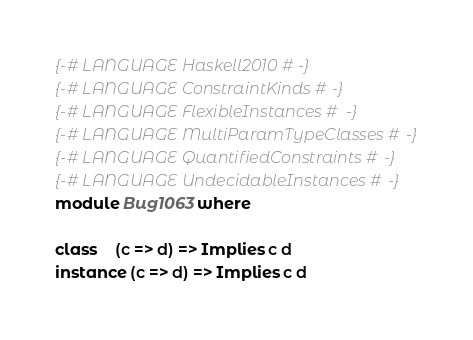Convert code to text. <code><loc_0><loc_0><loc_500><loc_500><_Haskell_>{-# LANGUAGE Haskell2010 #-}
{-# LANGUAGE ConstraintKinds #-}
{-# LANGUAGE FlexibleInstances #-}
{-# LANGUAGE MultiParamTypeClasses #-}
{-# LANGUAGE QuantifiedConstraints #-}
{-# LANGUAGE UndecidableInstances #-}
module Bug1063 where

class    (c => d) => Implies c d
instance (c => d) => Implies c d
</code> 